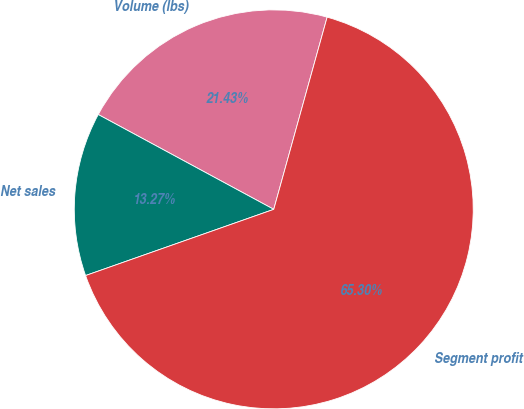<chart> <loc_0><loc_0><loc_500><loc_500><pie_chart><fcel>Volume (lbs)<fcel>Net sales<fcel>Segment profit<nl><fcel>21.43%<fcel>13.27%<fcel>65.31%<nl></chart> 